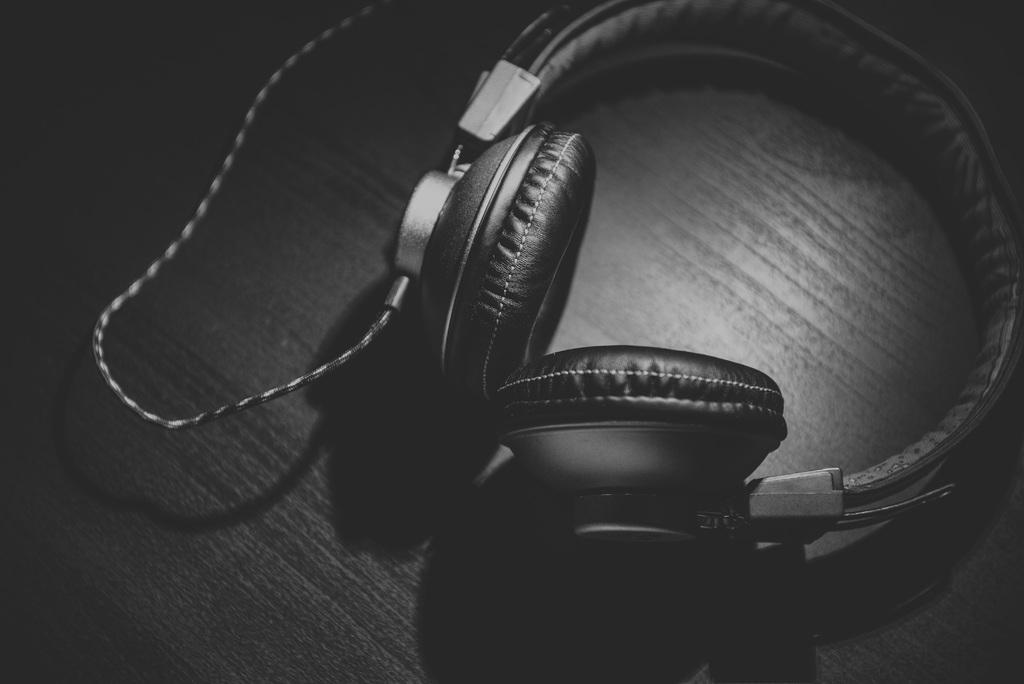What is the main object in the image? There is a headphone in the image. Where is the headphone located? The headphone is placed on a table. What type of beast can be seen interacting with the headphone in the image? There is no beast present in the image; it only features a headphone placed on a table. How many chickens are visible in the image? There are no chickens present in the image. 